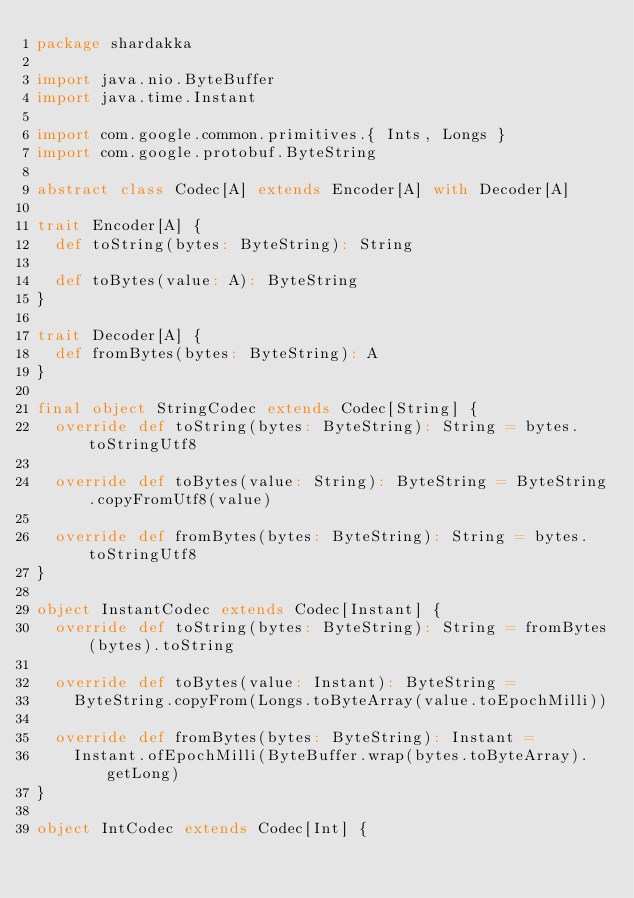Convert code to text. <code><loc_0><loc_0><loc_500><loc_500><_Scala_>package shardakka

import java.nio.ByteBuffer
import java.time.Instant

import com.google.common.primitives.{ Ints, Longs }
import com.google.protobuf.ByteString

abstract class Codec[A] extends Encoder[A] with Decoder[A]

trait Encoder[A] {
  def toString(bytes: ByteString): String

  def toBytes(value: A): ByteString
}

trait Decoder[A] {
  def fromBytes(bytes: ByteString): A
}

final object StringCodec extends Codec[String] {
  override def toString(bytes: ByteString): String = bytes.toStringUtf8

  override def toBytes(value: String): ByteString = ByteString.copyFromUtf8(value)

  override def fromBytes(bytes: ByteString): String = bytes.toStringUtf8
}

object InstantCodec extends Codec[Instant] {
  override def toString(bytes: ByteString): String = fromBytes(bytes).toString

  override def toBytes(value: Instant): ByteString =
    ByteString.copyFrom(Longs.toByteArray(value.toEpochMilli))

  override def fromBytes(bytes: ByteString): Instant =
    Instant.ofEpochMilli(ByteBuffer.wrap(bytes.toByteArray).getLong)
}

object IntCodec extends Codec[Int] {</code> 